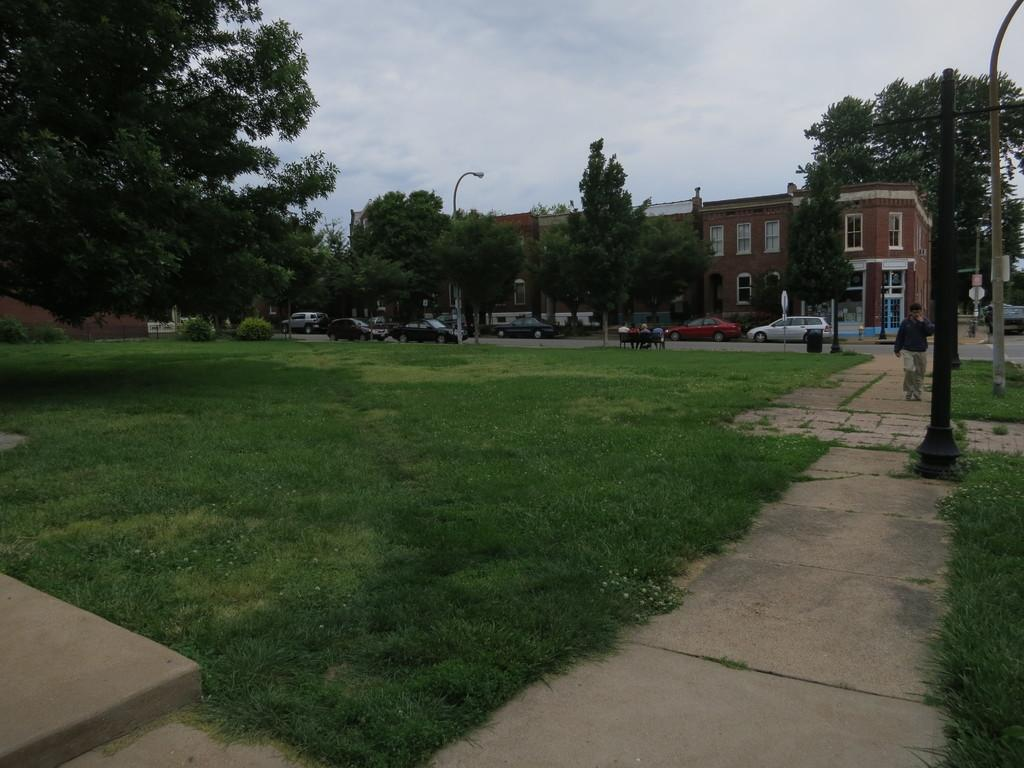What type of vegetation can be seen in the image? There is grass in the image. What else can be seen in the image besides the grass? There are vehicles, people sitting on a bench, trees, a street lamp, a current pole, and a building visible in the image. What is the sky's condition in the image? The sky is visible at the top of the image. What type of skirt is the jar wearing in the image? There is no skirt or jar present in the image. Can you describe the kiss between the two people sitting on the bench? There are no people kissing in the image; they are simply sitting on the bench. 